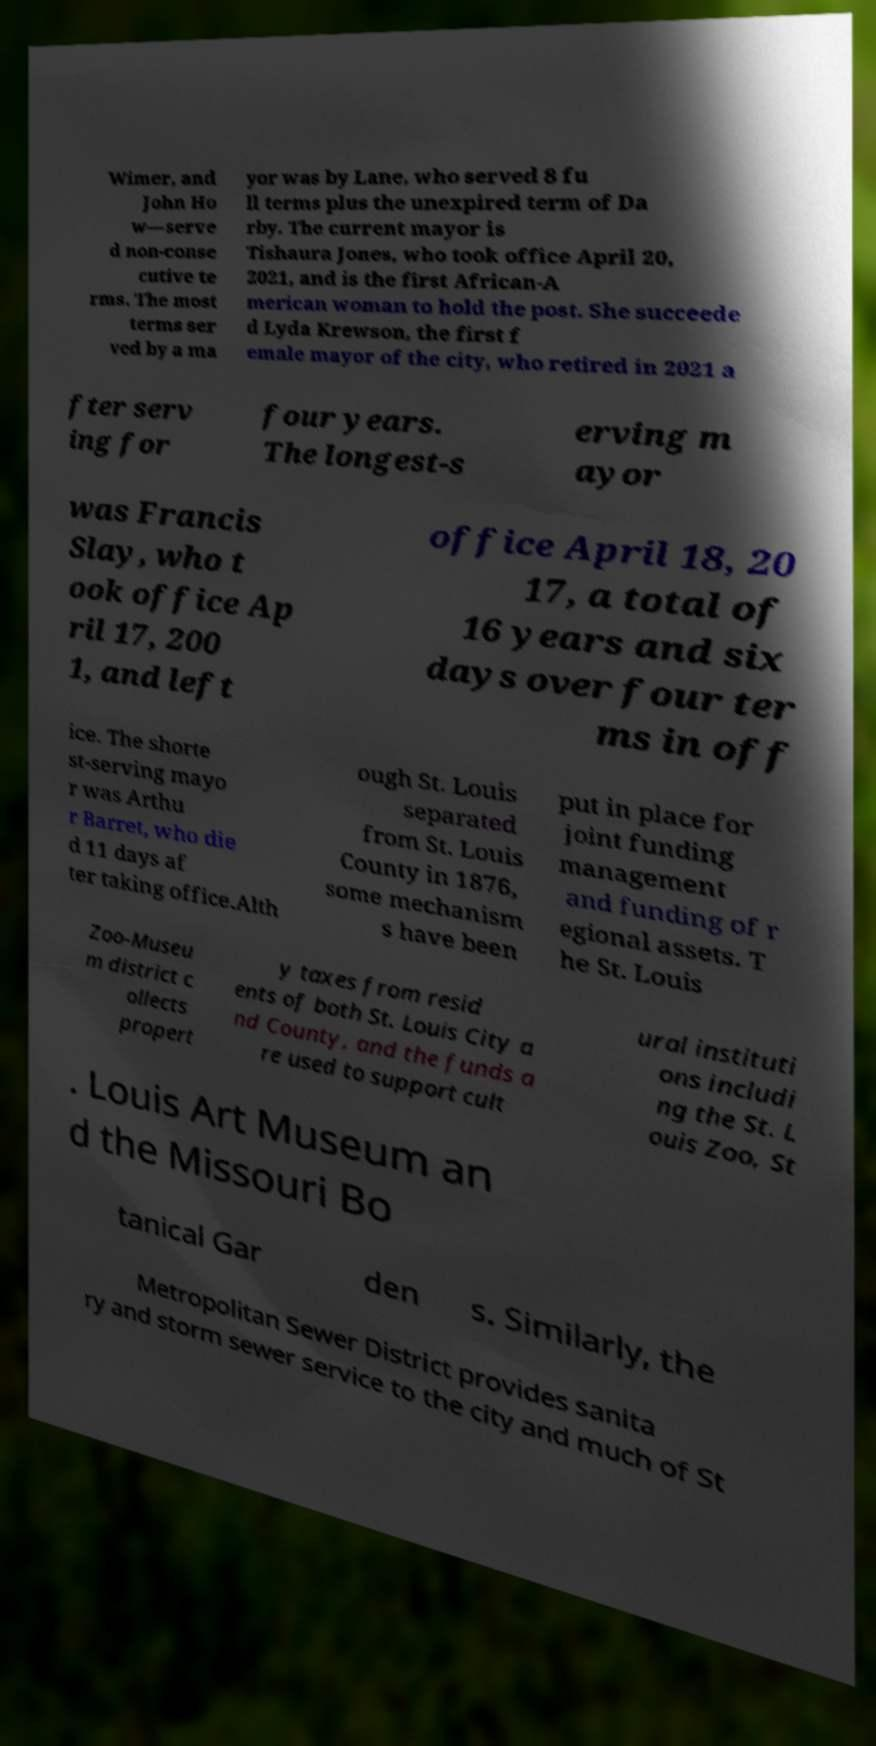Please identify and transcribe the text found in this image. Wimer, and John Ho w—serve d non-conse cutive te rms. The most terms ser ved by a ma yor was by Lane, who served 8 fu ll terms plus the unexpired term of Da rby. The current mayor is Tishaura Jones, who took office April 20, 2021, and is the first African-A merican woman to hold the post. She succeede d Lyda Krewson, the first f emale mayor of the city, who retired in 2021 a fter serv ing for four years. The longest-s erving m ayor was Francis Slay, who t ook office Ap ril 17, 200 1, and left office April 18, 20 17, a total of 16 years and six days over four ter ms in off ice. The shorte st-serving mayo r was Arthu r Barret, who die d 11 days af ter taking office.Alth ough St. Louis separated from St. Louis County in 1876, some mechanism s have been put in place for joint funding management and funding of r egional assets. T he St. Louis Zoo-Museu m district c ollects propert y taxes from resid ents of both St. Louis City a nd County, and the funds a re used to support cult ural instituti ons includi ng the St. L ouis Zoo, St . Louis Art Museum an d the Missouri Bo tanical Gar den s. Similarly, the Metropolitan Sewer District provides sanita ry and storm sewer service to the city and much of St 